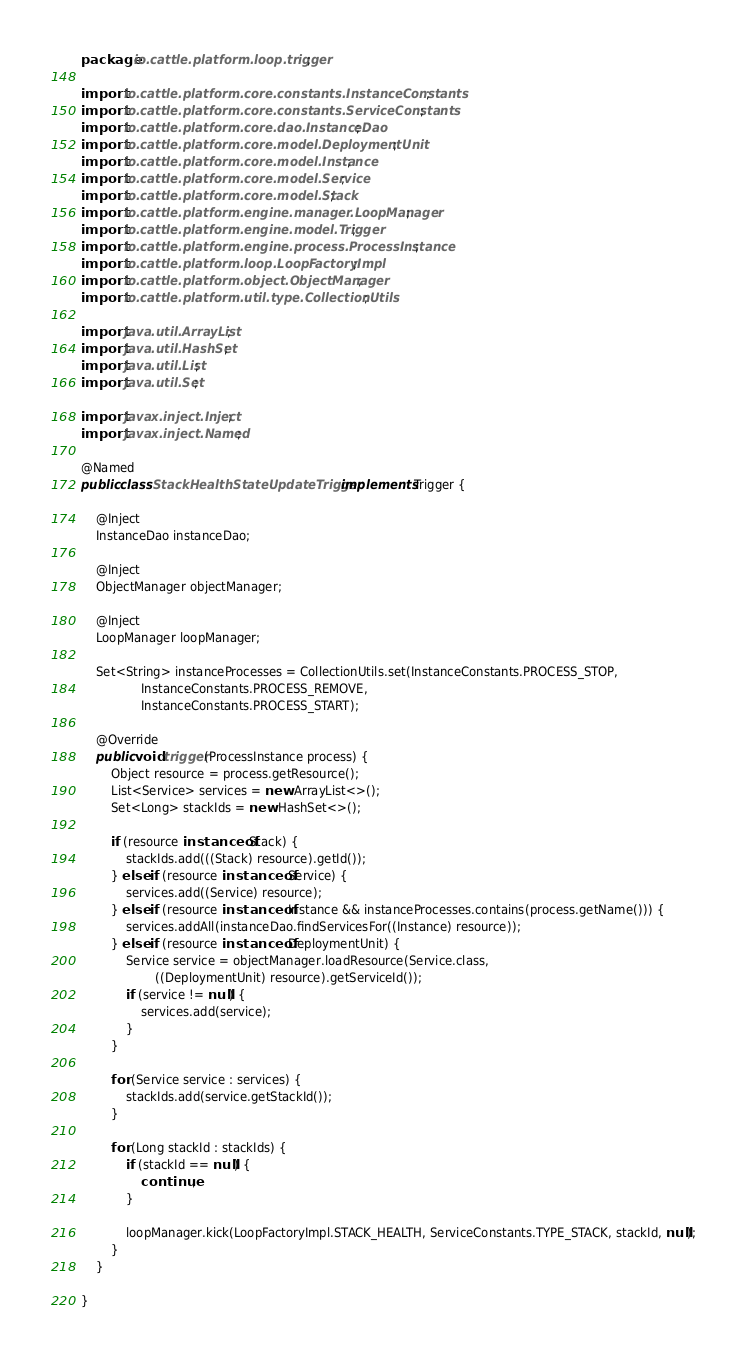Convert code to text. <code><loc_0><loc_0><loc_500><loc_500><_Java_>package io.cattle.platform.loop.trigger;

import io.cattle.platform.core.constants.InstanceConstants;
import io.cattle.platform.core.constants.ServiceConstants;
import io.cattle.platform.core.dao.InstanceDao;
import io.cattle.platform.core.model.DeploymentUnit;
import io.cattle.platform.core.model.Instance;
import io.cattle.platform.core.model.Service;
import io.cattle.platform.core.model.Stack;
import io.cattle.platform.engine.manager.LoopManager;
import io.cattle.platform.engine.model.Trigger;
import io.cattle.platform.engine.process.ProcessInstance;
import io.cattle.platform.loop.LoopFactoryImpl;
import io.cattle.platform.object.ObjectManager;
import io.cattle.platform.util.type.CollectionUtils;

import java.util.ArrayList;
import java.util.HashSet;
import java.util.List;
import java.util.Set;

import javax.inject.Inject;
import javax.inject.Named;

@Named
public class StackHealthStateUpdateTrigger implements Trigger {

    @Inject
    InstanceDao instanceDao;

    @Inject
    ObjectManager objectManager;

    @Inject
    LoopManager loopManager;

    Set<String> instanceProcesses = CollectionUtils.set(InstanceConstants.PROCESS_STOP,
                InstanceConstants.PROCESS_REMOVE,
                InstanceConstants.PROCESS_START);

    @Override
    public void trigger(ProcessInstance process) {
        Object resource = process.getResource();
        List<Service> services = new ArrayList<>();
        Set<Long> stackIds = new HashSet<>();

        if (resource instanceof Stack) {
            stackIds.add(((Stack) resource).getId());
        } else if (resource instanceof Service) {
            services.add((Service) resource);
        } else if (resource instanceof Instance && instanceProcesses.contains(process.getName())) {
            services.addAll(instanceDao.findServicesFor((Instance) resource));
        } else if (resource instanceof DeploymentUnit) {
            Service service = objectManager.loadResource(Service.class,
                    ((DeploymentUnit) resource).getServiceId());
            if (service != null) {
                services.add(service);
            }
        }

        for (Service service : services) {
            stackIds.add(service.getStackId());
        }

        for (Long stackId : stackIds) {
            if (stackId == null) {
                continue;
            }

            loopManager.kick(LoopFactoryImpl.STACK_HEALTH, ServiceConstants.TYPE_STACK, stackId, null);
        }
    }

}

</code> 